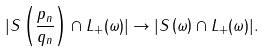Convert formula to latex. <formula><loc_0><loc_0><loc_500><loc_500>| S \left ( \frac { p _ { n } } { q _ { n } } \right ) \cap L _ { + } ( \omega ) | \to | S \left ( \omega \right ) \cap L _ { + } ( \omega ) | .</formula> 